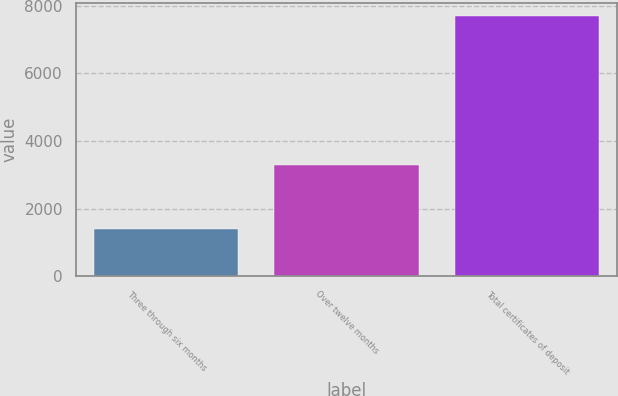Convert chart to OTSL. <chart><loc_0><loc_0><loc_500><loc_500><bar_chart><fcel>Three through six months<fcel>Over twelve months<fcel>Total certificates of deposit<nl><fcel>1384<fcel>3294<fcel>7702<nl></chart> 